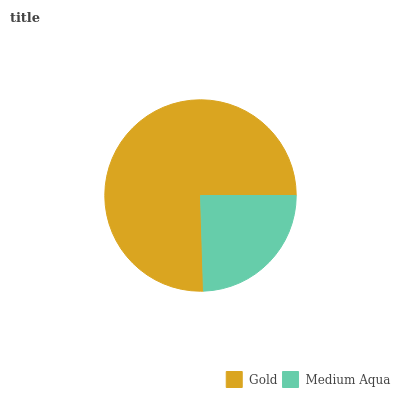Is Medium Aqua the minimum?
Answer yes or no. Yes. Is Gold the maximum?
Answer yes or no. Yes. Is Medium Aqua the maximum?
Answer yes or no. No. Is Gold greater than Medium Aqua?
Answer yes or no. Yes. Is Medium Aqua less than Gold?
Answer yes or no. Yes. Is Medium Aqua greater than Gold?
Answer yes or no. No. Is Gold less than Medium Aqua?
Answer yes or no. No. Is Gold the high median?
Answer yes or no. Yes. Is Medium Aqua the low median?
Answer yes or no. Yes. Is Medium Aqua the high median?
Answer yes or no. No. Is Gold the low median?
Answer yes or no. No. 